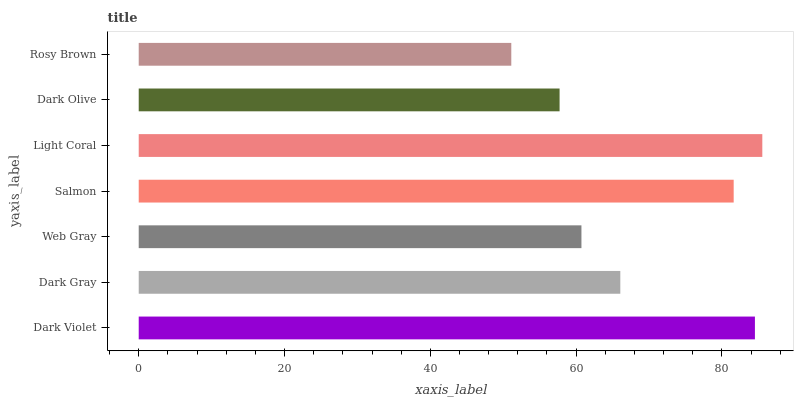Is Rosy Brown the minimum?
Answer yes or no. Yes. Is Light Coral the maximum?
Answer yes or no. Yes. Is Dark Gray the minimum?
Answer yes or no. No. Is Dark Gray the maximum?
Answer yes or no. No. Is Dark Violet greater than Dark Gray?
Answer yes or no. Yes. Is Dark Gray less than Dark Violet?
Answer yes or no. Yes. Is Dark Gray greater than Dark Violet?
Answer yes or no. No. Is Dark Violet less than Dark Gray?
Answer yes or no. No. Is Dark Gray the high median?
Answer yes or no. Yes. Is Dark Gray the low median?
Answer yes or no. Yes. Is Rosy Brown the high median?
Answer yes or no. No. Is Dark Olive the low median?
Answer yes or no. No. 